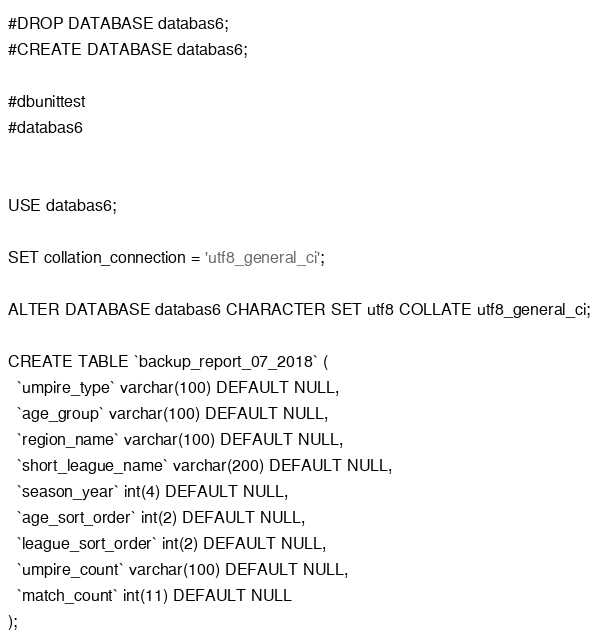Convert code to text. <code><loc_0><loc_0><loc_500><loc_500><_SQL_>#DROP DATABASE databas6;
#CREATE DATABASE databas6;

#dbunittest
#databas6


USE databas6;

SET collation_connection = 'utf8_general_ci';

ALTER DATABASE databas6 CHARACTER SET utf8 COLLATE utf8_general_ci;

CREATE TABLE `backup_report_07_2018` (
  `umpire_type` varchar(100) DEFAULT NULL,
  `age_group` varchar(100) DEFAULT NULL,
  `region_name` varchar(100) DEFAULT NULL,
  `short_league_name` varchar(200) DEFAULT NULL,
  `season_year` int(4) DEFAULT NULL,
  `age_sort_order` int(2) DEFAULT NULL,
  `league_sort_order` int(2) DEFAULT NULL,
  `umpire_count` varchar(100) DEFAULT NULL,
  `match_count` int(11) DEFAULT NULL
);

</code> 